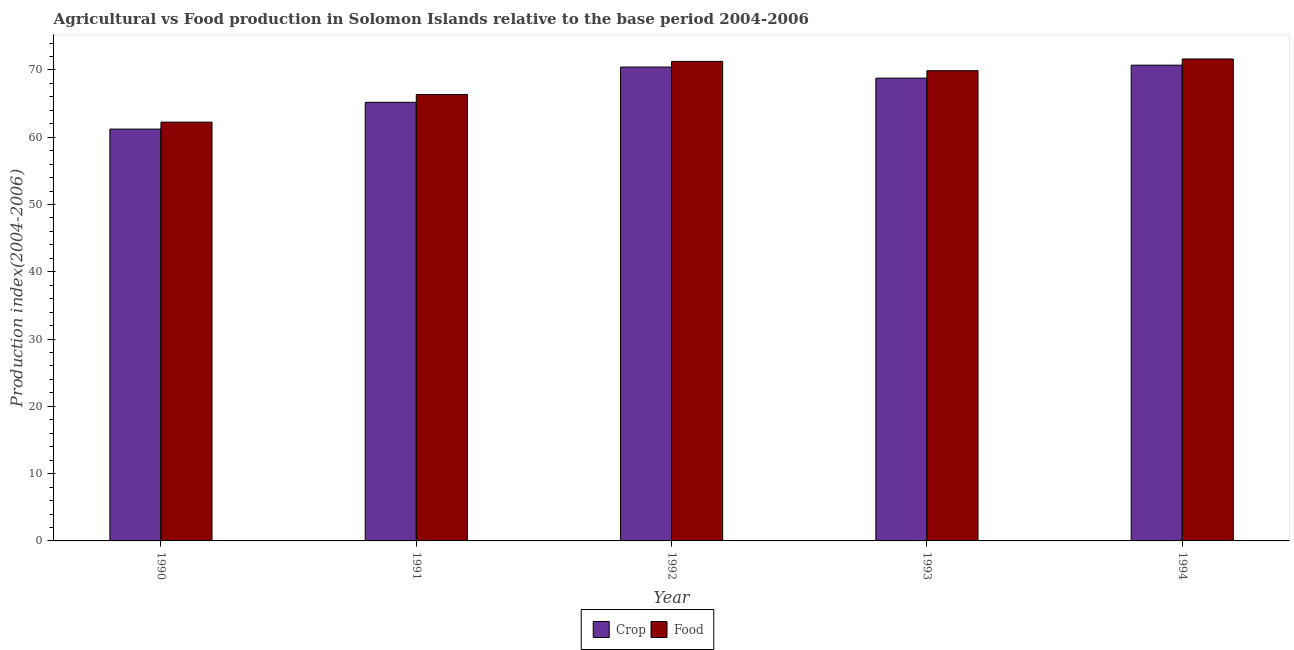How many different coloured bars are there?
Make the answer very short. 2. How many groups of bars are there?
Keep it short and to the point. 5. Are the number of bars per tick equal to the number of legend labels?
Your response must be concise. Yes. How many bars are there on the 5th tick from the left?
Your answer should be very brief. 2. How many bars are there on the 5th tick from the right?
Your answer should be very brief. 2. What is the label of the 3rd group of bars from the left?
Offer a very short reply. 1992. In how many cases, is the number of bars for a given year not equal to the number of legend labels?
Offer a terse response. 0. What is the food production index in 1991?
Make the answer very short. 66.35. Across all years, what is the maximum crop production index?
Offer a terse response. 70.71. Across all years, what is the minimum food production index?
Provide a succinct answer. 62.24. In which year was the food production index maximum?
Offer a very short reply. 1994. What is the total crop production index in the graph?
Provide a short and direct response. 336.32. What is the difference between the food production index in 1992 and that in 1993?
Ensure brevity in your answer.  1.38. What is the difference between the food production index in 1994 and the crop production index in 1991?
Your response must be concise. 5.28. What is the average food production index per year?
Ensure brevity in your answer.  68.28. What is the ratio of the food production index in 1992 to that in 1994?
Keep it short and to the point. 0.99. What is the difference between the highest and the second highest crop production index?
Offer a terse response. 0.28. What is the difference between the highest and the lowest food production index?
Give a very brief answer. 9.39. Is the sum of the food production index in 1991 and 1992 greater than the maximum crop production index across all years?
Give a very brief answer. Yes. What does the 1st bar from the left in 1990 represents?
Make the answer very short. Crop. What does the 2nd bar from the right in 1994 represents?
Offer a very short reply. Crop. Are all the bars in the graph horizontal?
Your answer should be compact. No. How many years are there in the graph?
Make the answer very short. 5. What is the difference between two consecutive major ticks on the Y-axis?
Your answer should be very brief. 10. Are the values on the major ticks of Y-axis written in scientific E-notation?
Provide a succinct answer. No. Does the graph contain grids?
Ensure brevity in your answer.  No. Where does the legend appear in the graph?
Your response must be concise. Bottom center. How are the legend labels stacked?
Keep it short and to the point. Horizontal. What is the title of the graph?
Ensure brevity in your answer.  Agricultural vs Food production in Solomon Islands relative to the base period 2004-2006. Does "Largest city" appear as one of the legend labels in the graph?
Ensure brevity in your answer.  No. What is the label or title of the X-axis?
Keep it short and to the point. Year. What is the label or title of the Y-axis?
Your answer should be compact. Production index(2004-2006). What is the Production index(2004-2006) of Crop in 1990?
Ensure brevity in your answer.  61.21. What is the Production index(2004-2006) of Food in 1990?
Your answer should be compact. 62.24. What is the Production index(2004-2006) of Crop in 1991?
Your answer should be very brief. 65.19. What is the Production index(2004-2006) in Food in 1991?
Make the answer very short. 66.35. What is the Production index(2004-2006) in Crop in 1992?
Your answer should be very brief. 70.43. What is the Production index(2004-2006) in Food in 1992?
Offer a very short reply. 71.27. What is the Production index(2004-2006) of Crop in 1993?
Ensure brevity in your answer.  68.78. What is the Production index(2004-2006) of Food in 1993?
Offer a very short reply. 69.89. What is the Production index(2004-2006) in Crop in 1994?
Your response must be concise. 70.71. What is the Production index(2004-2006) in Food in 1994?
Give a very brief answer. 71.63. Across all years, what is the maximum Production index(2004-2006) in Crop?
Your answer should be very brief. 70.71. Across all years, what is the maximum Production index(2004-2006) of Food?
Your answer should be compact. 71.63. Across all years, what is the minimum Production index(2004-2006) of Crop?
Provide a succinct answer. 61.21. Across all years, what is the minimum Production index(2004-2006) of Food?
Your answer should be very brief. 62.24. What is the total Production index(2004-2006) in Crop in the graph?
Give a very brief answer. 336.32. What is the total Production index(2004-2006) of Food in the graph?
Give a very brief answer. 341.38. What is the difference between the Production index(2004-2006) in Crop in 1990 and that in 1991?
Your answer should be compact. -3.98. What is the difference between the Production index(2004-2006) of Food in 1990 and that in 1991?
Your response must be concise. -4.11. What is the difference between the Production index(2004-2006) of Crop in 1990 and that in 1992?
Provide a succinct answer. -9.22. What is the difference between the Production index(2004-2006) in Food in 1990 and that in 1992?
Give a very brief answer. -9.03. What is the difference between the Production index(2004-2006) of Crop in 1990 and that in 1993?
Provide a short and direct response. -7.57. What is the difference between the Production index(2004-2006) in Food in 1990 and that in 1993?
Provide a short and direct response. -7.65. What is the difference between the Production index(2004-2006) in Crop in 1990 and that in 1994?
Your answer should be very brief. -9.5. What is the difference between the Production index(2004-2006) of Food in 1990 and that in 1994?
Give a very brief answer. -9.39. What is the difference between the Production index(2004-2006) in Crop in 1991 and that in 1992?
Offer a very short reply. -5.24. What is the difference between the Production index(2004-2006) of Food in 1991 and that in 1992?
Your response must be concise. -4.92. What is the difference between the Production index(2004-2006) of Crop in 1991 and that in 1993?
Ensure brevity in your answer.  -3.59. What is the difference between the Production index(2004-2006) of Food in 1991 and that in 1993?
Give a very brief answer. -3.54. What is the difference between the Production index(2004-2006) of Crop in 1991 and that in 1994?
Provide a succinct answer. -5.52. What is the difference between the Production index(2004-2006) in Food in 1991 and that in 1994?
Keep it short and to the point. -5.28. What is the difference between the Production index(2004-2006) in Crop in 1992 and that in 1993?
Your response must be concise. 1.65. What is the difference between the Production index(2004-2006) of Food in 1992 and that in 1993?
Your answer should be compact. 1.38. What is the difference between the Production index(2004-2006) of Crop in 1992 and that in 1994?
Offer a terse response. -0.28. What is the difference between the Production index(2004-2006) of Food in 1992 and that in 1994?
Ensure brevity in your answer.  -0.36. What is the difference between the Production index(2004-2006) in Crop in 1993 and that in 1994?
Provide a short and direct response. -1.93. What is the difference between the Production index(2004-2006) in Food in 1993 and that in 1994?
Your response must be concise. -1.74. What is the difference between the Production index(2004-2006) in Crop in 1990 and the Production index(2004-2006) in Food in 1991?
Provide a short and direct response. -5.14. What is the difference between the Production index(2004-2006) in Crop in 1990 and the Production index(2004-2006) in Food in 1992?
Offer a very short reply. -10.06. What is the difference between the Production index(2004-2006) of Crop in 1990 and the Production index(2004-2006) of Food in 1993?
Make the answer very short. -8.68. What is the difference between the Production index(2004-2006) in Crop in 1990 and the Production index(2004-2006) in Food in 1994?
Offer a terse response. -10.42. What is the difference between the Production index(2004-2006) in Crop in 1991 and the Production index(2004-2006) in Food in 1992?
Make the answer very short. -6.08. What is the difference between the Production index(2004-2006) in Crop in 1991 and the Production index(2004-2006) in Food in 1994?
Give a very brief answer. -6.44. What is the difference between the Production index(2004-2006) in Crop in 1992 and the Production index(2004-2006) in Food in 1993?
Give a very brief answer. 0.54. What is the difference between the Production index(2004-2006) of Crop in 1992 and the Production index(2004-2006) of Food in 1994?
Give a very brief answer. -1.2. What is the difference between the Production index(2004-2006) of Crop in 1993 and the Production index(2004-2006) of Food in 1994?
Your answer should be very brief. -2.85. What is the average Production index(2004-2006) of Crop per year?
Make the answer very short. 67.26. What is the average Production index(2004-2006) in Food per year?
Give a very brief answer. 68.28. In the year 1990, what is the difference between the Production index(2004-2006) of Crop and Production index(2004-2006) of Food?
Your response must be concise. -1.03. In the year 1991, what is the difference between the Production index(2004-2006) in Crop and Production index(2004-2006) in Food?
Ensure brevity in your answer.  -1.16. In the year 1992, what is the difference between the Production index(2004-2006) of Crop and Production index(2004-2006) of Food?
Provide a short and direct response. -0.84. In the year 1993, what is the difference between the Production index(2004-2006) of Crop and Production index(2004-2006) of Food?
Keep it short and to the point. -1.11. In the year 1994, what is the difference between the Production index(2004-2006) in Crop and Production index(2004-2006) in Food?
Keep it short and to the point. -0.92. What is the ratio of the Production index(2004-2006) in Crop in 1990 to that in 1991?
Your answer should be very brief. 0.94. What is the ratio of the Production index(2004-2006) of Food in 1990 to that in 1991?
Your answer should be compact. 0.94. What is the ratio of the Production index(2004-2006) of Crop in 1990 to that in 1992?
Your answer should be compact. 0.87. What is the ratio of the Production index(2004-2006) in Food in 1990 to that in 1992?
Provide a short and direct response. 0.87. What is the ratio of the Production index(2004-2006) in Crop in 1990 to that in 1993?
Your answer should be compact. 0.89. What is the ratio of the Production index(2004-2006) in Food in 1990 to that in 1993?
Provide a short and direct response. 0.89. What is the ratio of the Production index(2004-2006) in Crop in 1990 to that in 1994?
Your answer should be compact. 0.87. What is the ratio of the Production index(2004-2006) in Food in 1990 to that in 1994?
Offer a very short reply. 0.87. What is the ratio of the Production index(2004-2006) of Crop in 1991 to that in 1992?
Give a very brief answer. 0.93. What is the ratio of the Production index(2004-2006) of Food in 1991 to that in 1992?
Offer a terse response. 0.93. What is the ratio of the Production index(2004-2006) of Crop in 1991 to that in 1993?
Offer a terse response. 0.95. What is the ratio of the Production index(2004-2006) in Food in 1991 to that in 1993?
Your answer should be compact. 0.95. What is the ratio of the Production index(2004-2006) of Crop in 1991 to that in 1994?
Offer a terse response. 0.92. What is the ratio of the Production index(2004-2006) of Food in 1991 to that in 1994?
Give a very brief answer. 0.93. What is the ratio of the Production index(2004-2006) of Food in 1992 to that in 1993?
Provide a short and direct response. 1.02. What is the ratio of the Production index(2004-2006) of Crop in 1993 to that in 1994?
Ensure brevity in your answer.  0.97. What is the ratio of the Production index(2004-2006) of Food in 1993 to that in 1994?
Your answer should be very brief. 0.98. What is the difference between the highest and the second highest Production index(2004-2006) of Crop?
Offer a very short reply. 0.28. What is the difference between the highest and the second highest Production index(2004-2006) of Food?
Your answer should be compact. 0.36. What is the difference between the highest and the lowest Production index(2004-2006) in Crop?
Provide a short and direct response. 9.5. What is the difference between the highest and the lowest Production index(2004-2006) of Food?
Keep it short and to the point. 9.39. 